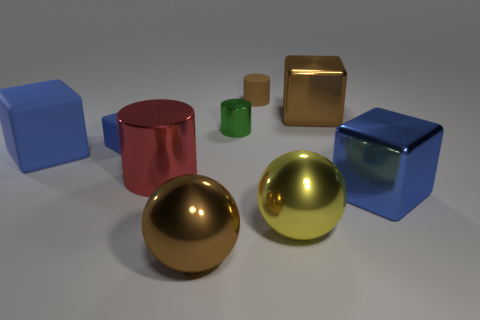How many other objects are the same color as the tiny block?
Keep it short and to the point. 2. The big block that is both in front of the tiny green shiny thing and right of the small rubber cube is what color?
Give a very brief answer. Blue. There is a rubber object that is the same size as the yellow metal object; what is its shape?
Offer a terse response. Cube. Are there any brown rubber objects that have the same shape as the small green shiny thing?
Keep it short and to the point. Yes. Is the material of the yellow object the same as the block to the right of the large brown metal block?
Provide a succinct answer. Yes. What color is the cylinder in front of the large blue thing that is left of the sphere left of the small brown rubber cylinder?
Your response must be concise. Red. There is a cylinder that is the same size as the blue metallic object; what is it made of?
Offer a terse response. Metal. How many large blue blocks are the same material as the small blue thing?
Provide a succinct answer. 1. Is the size of the red object that is in front of the brown matte object the same as the matte thing that is to the right of the tiny metal object?
Your answer should be compact. No. What is the color of the large shiny block that is behind the big cylinder?
Provide a succinct answer. Brown. 